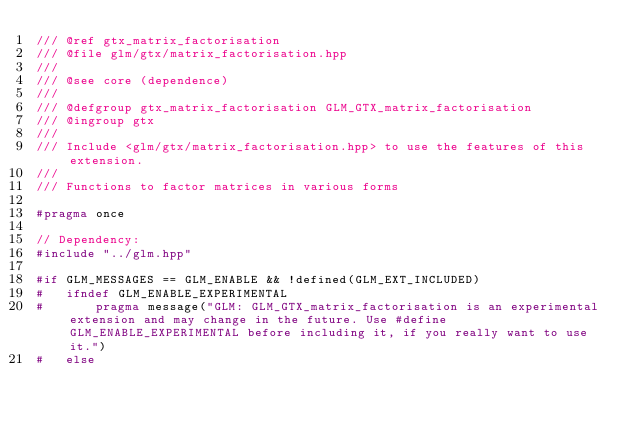<code> <loc_0><loc_0><loc_500><loc_500><_C++_>/// @ref gtx_matrix_factorisation
/// @file glm/gtx/matrix_factorisation.hpp
///
/// @see core (dependence)
///
/// @defgroup gtx_matrix_factorisation GLM_GTX_matrix_factorisation
/// @ingroup gtx
///
/// Include <glm/gtx/matrix_factorisation.hpp> to use the features of this extension.
///
/// Functions to factor matrices in various forms

#pragma once

// Dependency:
#include "../glm.hpp"

#if GLM_MESSAGES == GLM_ENABLE && !defined(GLM_EXT_INCLUDED)
#	ifndef GLM_ENABLE_EXPERIMENTAL
#		pragma message("GLM: GLM_GTX_matrix_factorisation is an experimental extension and may change in the future. Use #define GLM_ENABLE_EXPERIMENTAL before including it, if you really want to use it.")
#	else</code> 